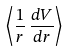Convert formula to latex. <formula><loc_0><loc_0><loc_500><loc_500>\left \langle \frac { 1 } { r } \, \frac { d V } { d r } \right \rangle</formula> 